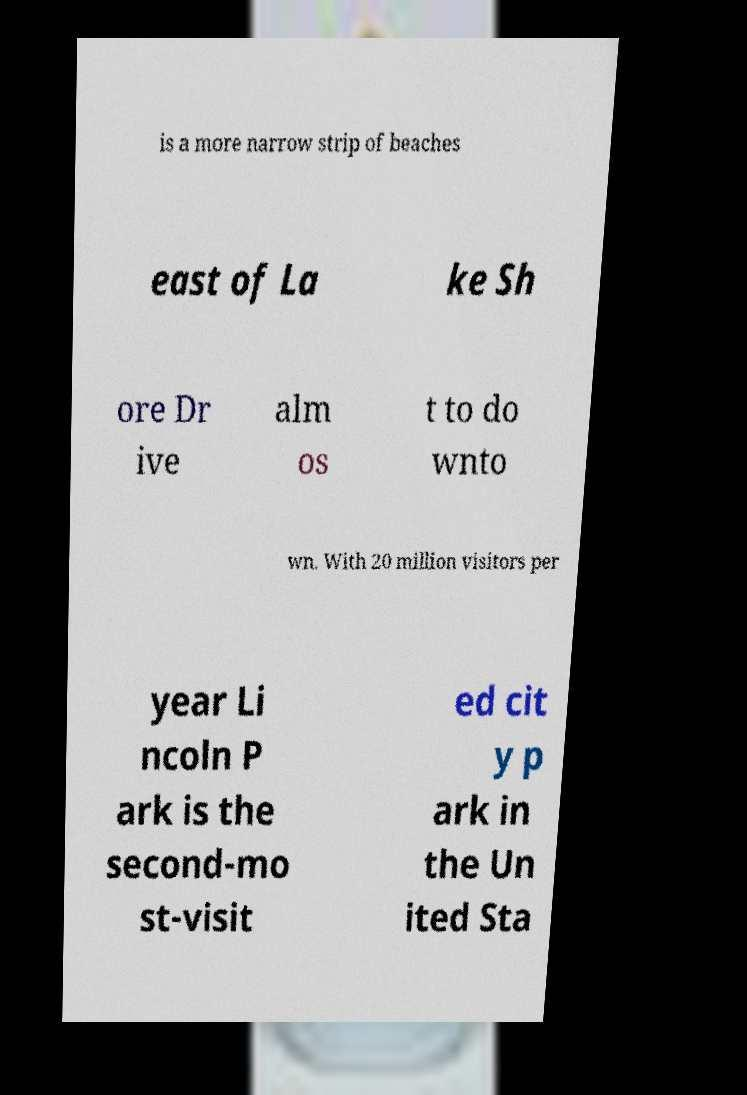There's text embedded in this image that I need extracted. Can you transcribe it verbatim? is a more narrow strip of beaches east of La ke Sh ore Dr ive alm os t to do wnto wn. With 20 million visitors per year Li ncoln P ark is the second-mo st-visit ed cit y p ark in the Un ited Sta 